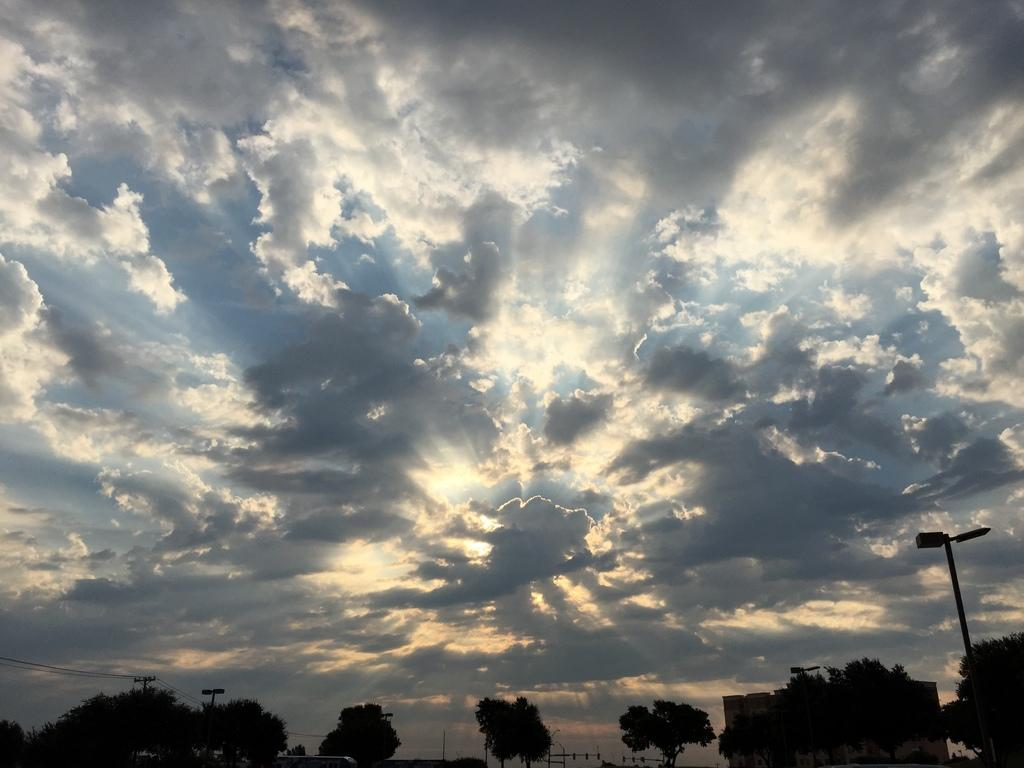Where was the image taken? The image was taken outdoors. What can be seen in the sky in the image? There is a sky with clouds in the image. What type of vegetation is visible at the bottom of the image? There are trees at the bottom of the image. What type of structures are present in the image? There are poles with street lights in the image. What type of haircut is the tree on the left side of the image getting? There is no tree getting a haircut in the image, and trees do not receive haircuts. What type of teeth can be seen on the street lights in the image? There are no teeth present on the street lights in the image. 